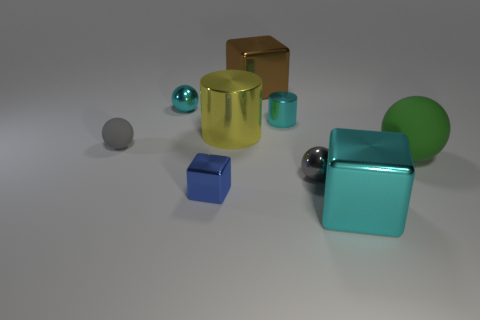Is the material of the big yellow object the same as the brown thing?
Offer a terse response. Yes. What number of blue metal cubes are on the left side of the yellow cylinder?
Keep it short and to the point. 1. There is a thing that is both in front of the large rubber object and behind the blue object; what material is it?
Keep it short and to the point. Metal. What number of cyan things have the same size as the cyan cylinder?
Ensure brevity in your answer.  1. What is the color of the big cube to the left of the gray object in front of the green rubber ball?
Your answer should be very brief. Brown. Is there a big purple metallic block?
Your answer should be very brief. No. Is the shape of the large green matte object the same as the tiny blue object?
Your response must be concise. No. There is a metallic sphere that is the same color as the tiny cylinder; what size is it?
Your answer should be compact. Small. How many cyan objects are left of the large metal object that is behind the large yellow metal cylinder?
Your answer should be very brief. 1. How many blocks are right of the tiny gray metallic ball and behind the small blue shiny cube?
Make the answer very short. 0. 